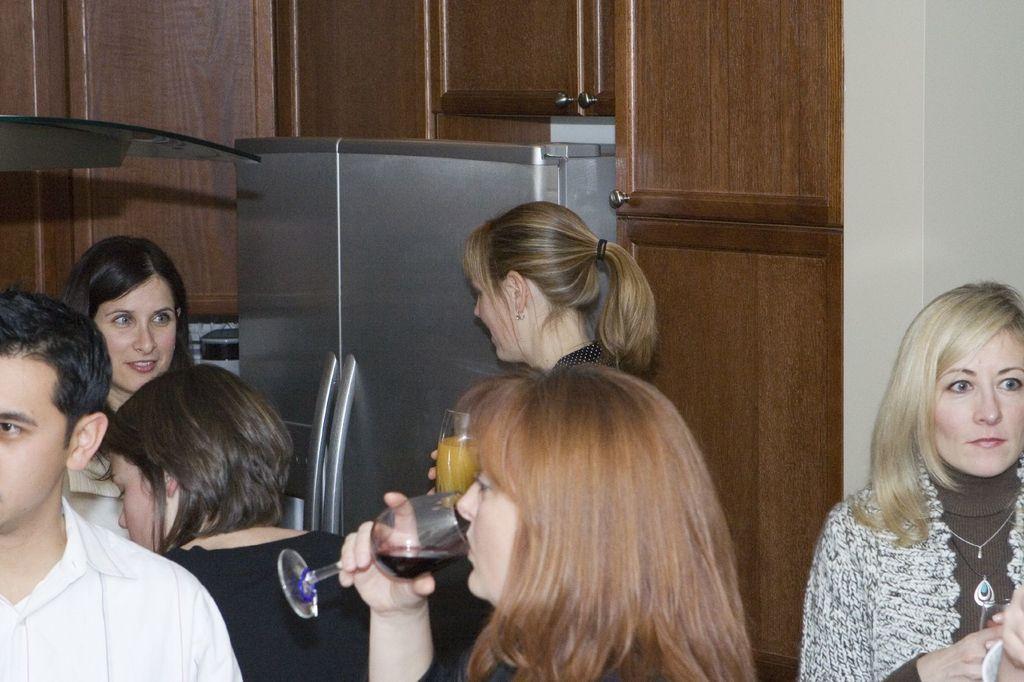Describe this image in one or two sentences. There is a group of a people. In the center we have a woman. she is drinking a wine. In background we can see cupboard. 